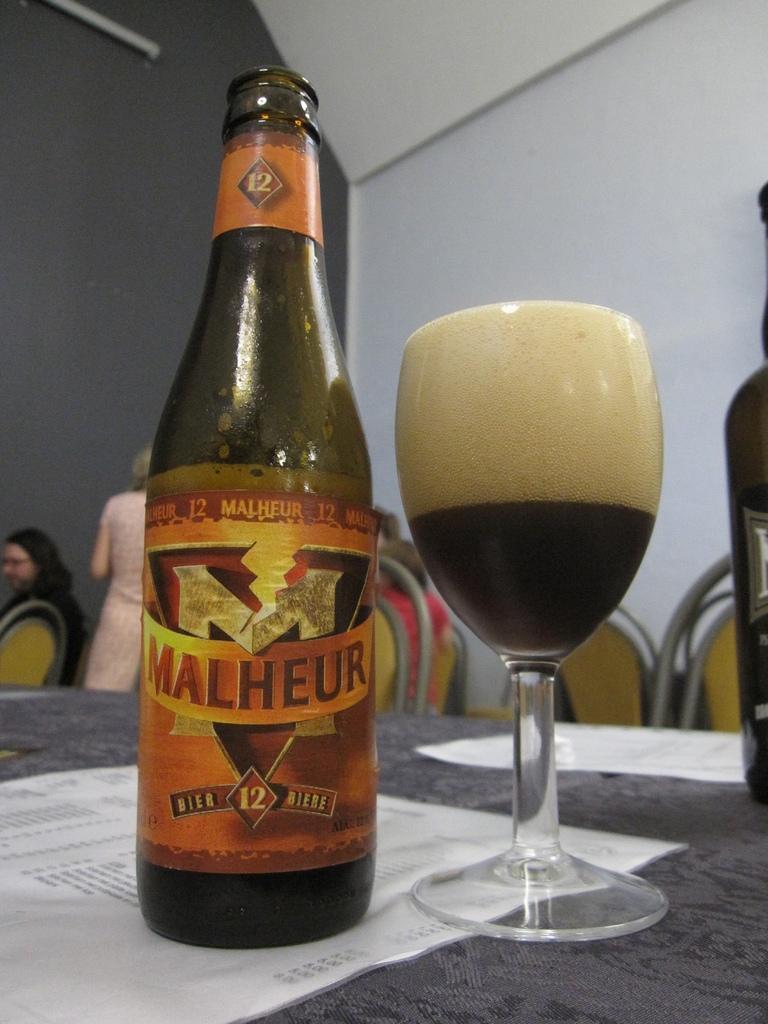Please provide a concise description of this image. This is the picture of a room. In this image there are bottles, papers and there is a glass on the table. At the back there are group of people sitting and there is a person standing and there are chairs. At the top there is a tube light. 